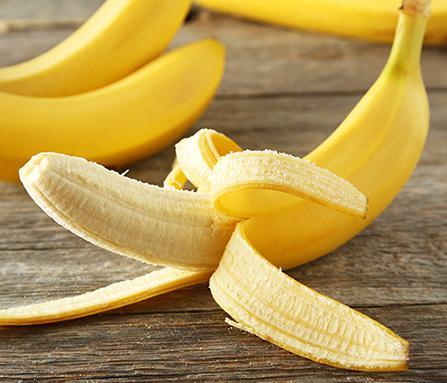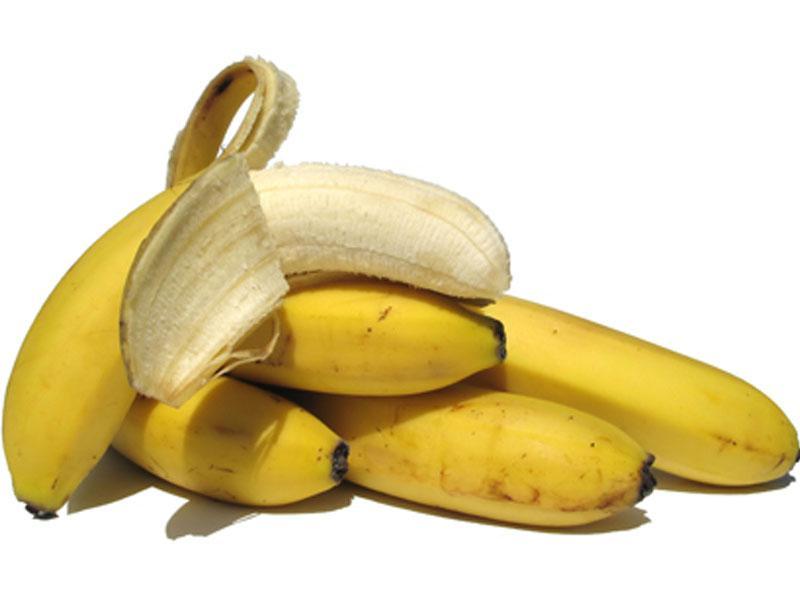The first image is the image on the left, the second image is the image on the right. For the images displayed, is the sentence "One image shows a beverage in a clear glass in front of joined bananas, and the other image contains only yellow bananas in a bunch." factually correct? Answer yes or no. No. The first image is the image on the left, the second image is the image on the right. Evaluate the accuracy of this statement regarding the images: "A glass sits near a few bananas in one of the images.". Is it true? Answer yes or no. No. 